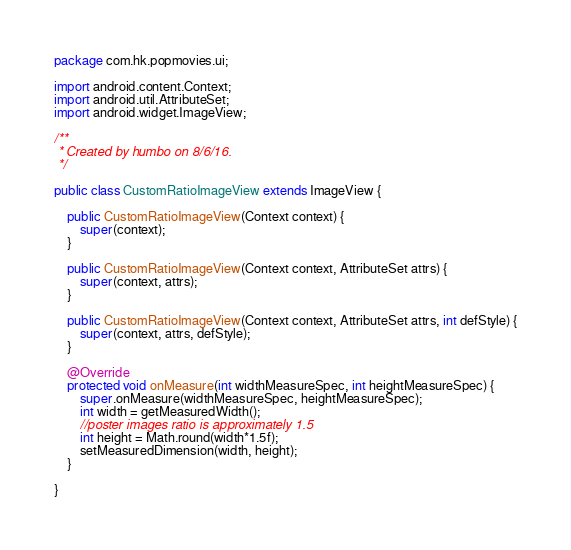<code> <loc_0><loc_0><loc_500><loc_500><_Java_>package com.hk.popmovies.ui;

import android.content.Context;
import android.util.AttributeSet;
import android.widget.ImageView;

/**
 * Created by humbo on 8/6/16.
 */

public class CustomRatioImageView extends ImageView {

    public CustomRatioImageView(Context context) {
        super(context);
    }

    public CustomRatioImageView(Context context, AttributeSet attrs) {
        super(context, attrs);
    }

    public CustomRatioImageView(Context context, AttributeSet attrs, int defStyle) {
        super(context, attrs, defStyle);
    }

    @Override
    protected void onMeasure(int widthMeasureSpec, int heightMeasureSpec) {
        super.onMeasure(widthMeasureSpec, heightMeasureSpec);
        int width = getMeasuredWidth();
        //poster images ratio is approximately 1.5
        int height = Math.round(width*1.5f);
        setMeasuredDimension(width, height);
    }

}</code> 